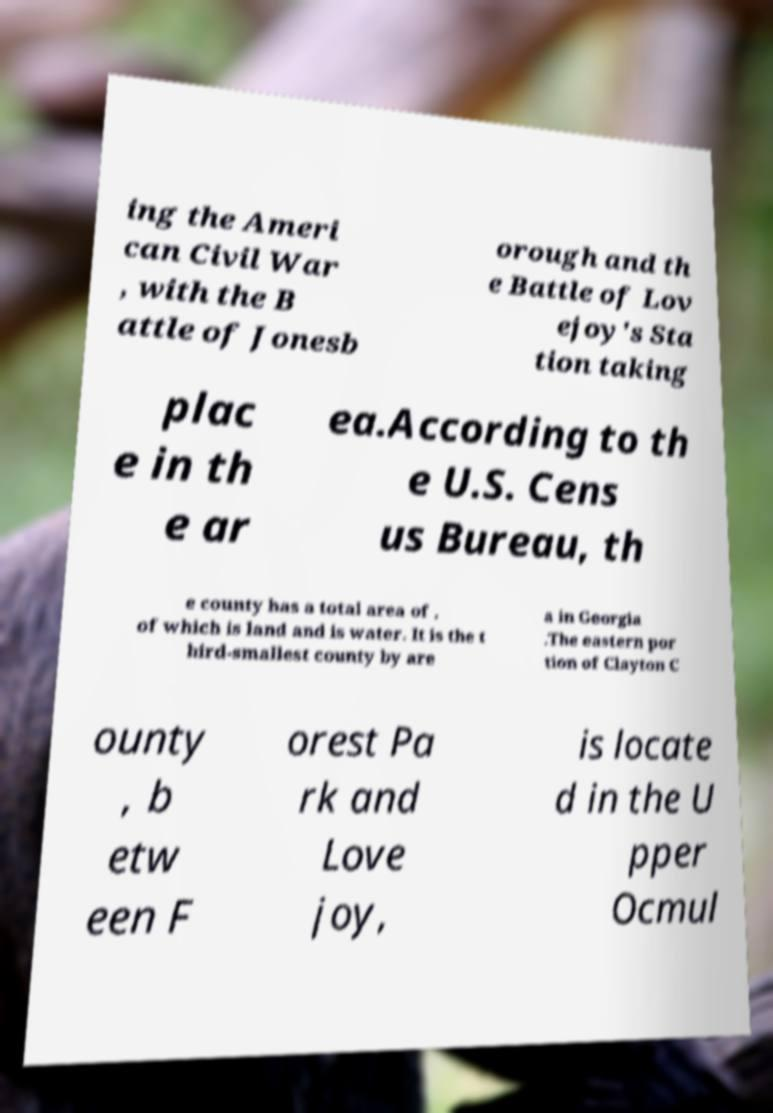Can you accurately transcribe the text from the provided image for me? ing the Ameri can Civil War , with the B attle of Jonesb orough and th e Battle of Lov ejoy's Sta tion taking plac e in th e ar ea.According to th e U.S. Cens us Bureau, th e county has a total area of , of which is land and is water. It is the t hird-smallest county by are a in Georgia .The eastern por tion of Clayton C ounty , b etw een F orest Pa rk and Love joy, is locate d in the U pper Ocmul 